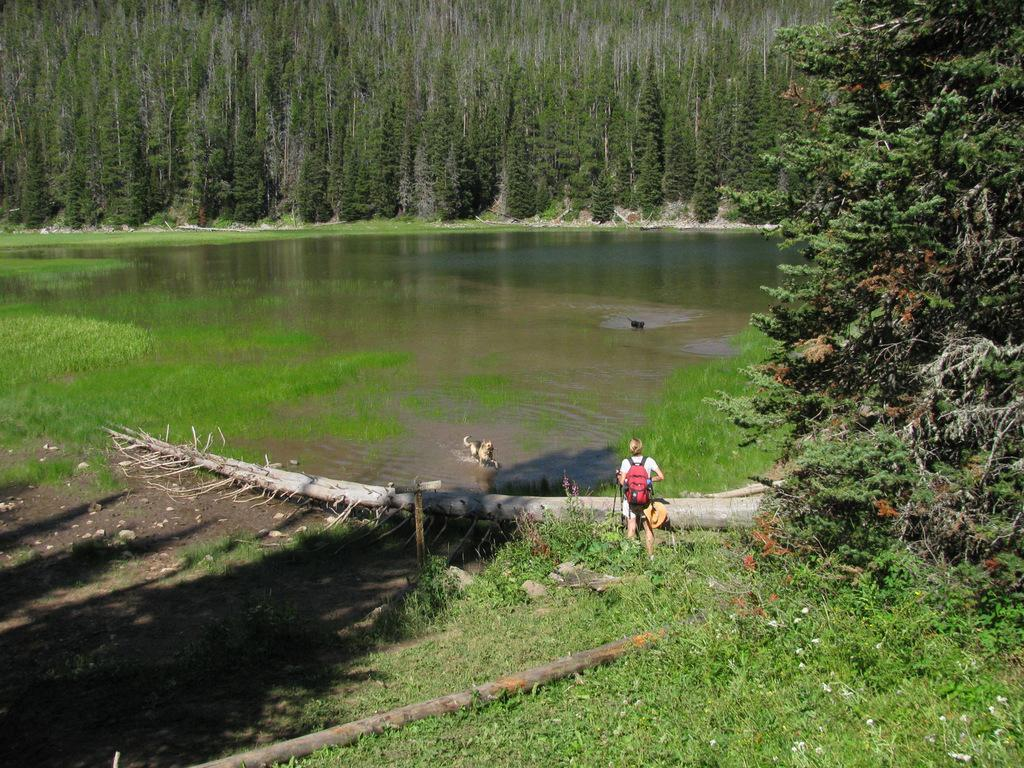Who or what is present in the image with the person? There is a dog in the image with the person. What is the person wearing that is visible in the image? The person is wearing a bag. What is in front of the person in the image? There is a wooden bark in front of the person. What can be seen in the distance in the image? There is water and trees visible in the background of the image. What type of drum is being played by the person in the image? There is no drum present in the image; the person is not playing any musical instrument. 